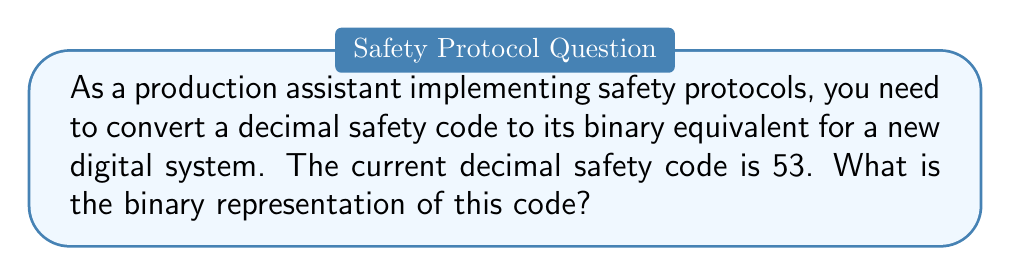Can you answer this question? To convert a decimal number to binary, we use the following steps:

1. Divide the decimal number by 2.
2. Keep track of the remainder (0 or 1).
3. Continue dividing the quotient by 2 until the quotient becomes 0.
4. Read the remainders from bottom to top to get the binary number.

Let's convert 53 to binary:

$$
\begin{align*}
53 \div 2 &= 26 \text{ remainder } 1 \\
26 \div 2 &= 13 \text{ remainder } 0 \\
13 \div 2 &= 6 \text{ remainder } 1 \\
6 \div 2 &= 3 \text{ remainder } 0 \\
3 \div 2 &= 1 \text{ remainder } 1 \\
1 \div 2 &= 0 \text{ remainder } 1
\end{align*}
$$

Reading the remainders from bottom to top, we get:

$53_{10} = 110101_2$

To verify, we can convert the binary number back to decimal:

$$
\begin{align*}
110101_2 &= 1\times2^5 + 1\times2^4 + 0\times2^3 + 1\times2^2 + 0\times2^1 + 1\times2^0 \\
&= 32 + 16 + 0 + 4 + 0 + 1 \\
&= 53_{10}
\end{align*}
$$

This confirms that our conversion is correct.
Answer: $110101_2$ 